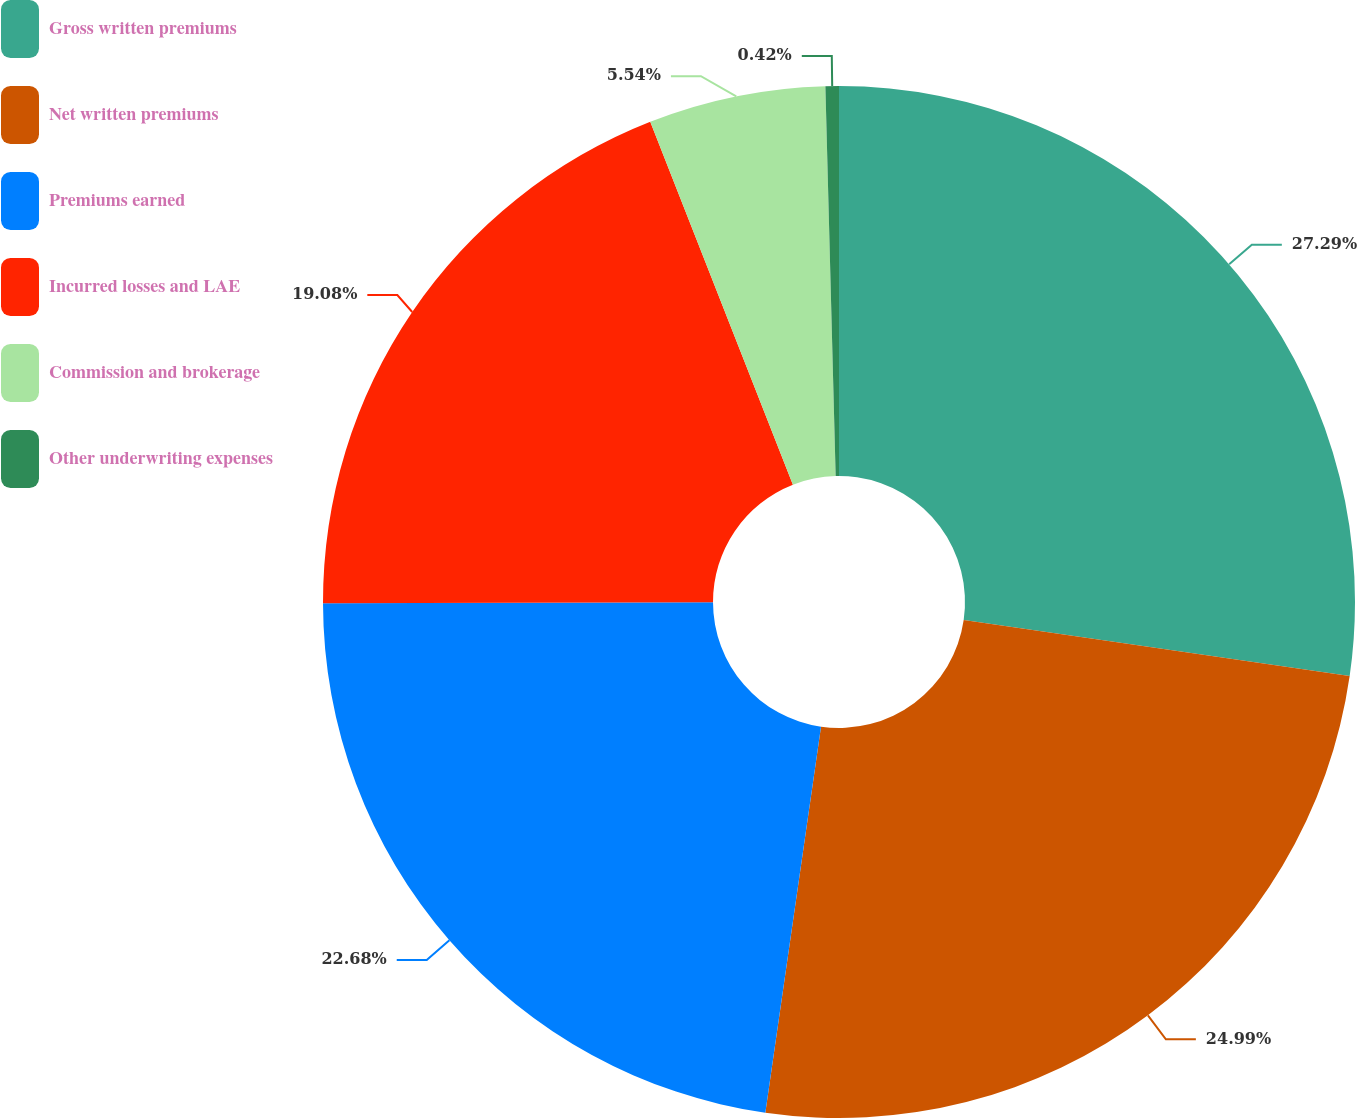<chart> <loc_0><loc_0><loc_500><loc_500><pie_chart><fcel>Gross written premiums<fcel>Net written premiums<fcel>Premiums earned<fcel>Incurred losses and LAE<fcel>Commission and brokerage<fcel>Other underwriting expenses<nl><fcel>27.29%<fcel>24.99%<fcel>22.68%<fcel>19.08%<fcel>5.54%<fcel>0.42%<nl></chart> 